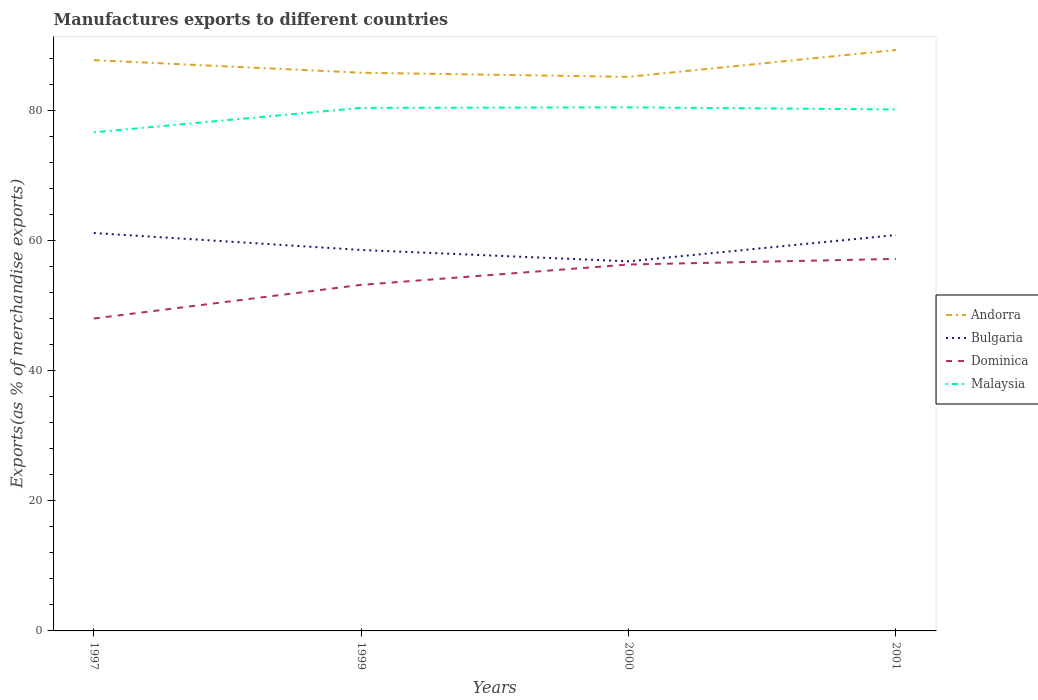How many different coloured lines are there?
Your response must be concise. 4. Is the number of lines equal to the number of legend labels?
Give a very brief answer. Yes. Across all years, what is the maximum percentage of exports to different countries in Bulgaria?
Offer a terse response. 56.77. What is the total percentage of exports to different countries in Andorra in the graph?
Make the answer very short. -1.56. What is the difference between the highest and the second highest percentage of exports to different countries in Bulgaria?
Give a very brief answer. 4.35. What is the difference between the highest and the lowest percentage of exports to different countries in Andorra?
Give a very brief answer. 2. Is the percentage of exports to different countries in Andorra strictly greater than the percentage of exports to different countries in Malaysia over the years?
Give a very brief answer. No. What is the difference between two consecutive major ticks on the Y-axis?
Offer a very short reply. 20. Does the graph contain any zero values?
Ensure brevity in your answer.  No. How are the legend labels stacked?
Your answer should be very brief. Vertical. What is the title of the graph?
Keep it short and to the point. Manufactures exports to different countries. What is the label or title of the Y-axis?
Your answer should be very brief. Exports(as % of merchandise exports). What is the Exports(as % of merchandise exports) of Andorra in 1997?
Your answer should be compact. 87.68. What is the Exports(as % of merchandise exports) in Bulgaria in 1997?
Keep it short and to the point. 61.13. What is the Exports(as % of merchandise exports) in Dominica in 1997?
Give a very brief answer. 47.99. What is the Exports(as % of merchandise exports) of Malaysia in 1997?
Offer a very short reply. 76.59. What is the Exports(as % of merchandise exports) in Andorra in 1999?
Your answer should be very brief. 85.75. What is the Exports(as % of merchandise exports) in Bulgaria in 1999?
Offer a terse response. 58.52. What is the Exports(as % of merchandise exports) in Dominica in 1999?
Offer a terse response. 53.16. What is the Exports(as % of merchandise exports) of Malaysia in 1999?
Your response must be concise. 80.35. What is the Exports(as % of merchandise exports) in Andorra in 2000?
Your answer should be compact. 85.12. What is the Exports(as % of merchandise exports) in Bulgaria in 2000?
Make the answer very short. 56.77. What is the Exports(as % of merchandise exports) of Dominica in 2000?
Give a very brief answer. 56.29. What is the Exports(as % of merchandise exports) in Malaysia in 2000?
Your answer should be compact. 80.43. What is the Exports(as % of merchandise exports) of Andorra in 2001?
Your answer should be compact. 89.24. What is the Exports(as % of merchandise exports) in Bulgaria in 2001?
Ensure brevity in your answer.  60.82. What is the Exports(as % of merchandise exports) in Dominica in 2001?
Offer a terse response. 57.15. What is the Exports(as % of merchandise exports) in Malaysia in 2001?
Offer a very short reply. 80.11. Across all years, what is the maximum Exports(as % of merchandise exports) of Andorra?
Your answer should be very brief. 89.24. Across all years, what is the maximum Exports(as % of merchandise exports) of Bulgaria?
Offer a very short reply. 61.13. Across all years, what is the maximum Exports(as % of merchandise exports) of Dominica?
Provide a succinct answer. 57.15. Across all years, what is the maximum Exports(as % of merchandise exports) of Malaysia?
Provide a succinct answer. 80.43. Across all years, what is the minimum Exports(as % of merchandise exports) in Andorra?
Offer a very short reply. 85.12. Across all years, what is the minimum Exports(as % of merchandise exports) in Bulgaria?
Your answer should be very brief. 56.77. Across all years, what is the minimum Exports(as % of merchandise exports) of Dominica?
Your answer should be compact. 47.99. Across all years, what is the minimum Exports(as % of merchandise exports) of Malaysia?
Offer a very short reply. 76.59. What is the total Exports(as % of merchandise exports) of Andorra in the graph?
Keep it short and to the point. 347.79. What is the total Exports(as % of merchandise exports) of Bulgaria in the graph?
Offer a very short reply. 237.24. What is the total Exports(as % of merchandise exports) in Dominica in the graph?
Provide a succinct answer. 214.59. What is the total Exports(as % of merchandise exports) of Malaysia in the graph?
Provide a short and direct response. 317.49. What is the difference between the Exports(as % of merchandise exports) in Andorra in 1997 and that in 1999?
Provide a short and direct response. 1.94. What is the difference between the Exports(as % of merchandise exports) in Bulgaria in 1997 and that in 1999?
Provide a succinct answer. 2.61. What is the difference between the Exports(as % of merchandise exports) in Dominica in 1997 and that in 1999?
Keep it short and to the point. -5.17. What is the difference between the Exports(as % of merchandise exports) in Malaysia in 1997 and that in 1999?
Keep it short and to the point. -3.76. What is the difference between the Exports(as % of merchandise exports) of Andorra in 1997 and that in 2000?
Provide a succinct answer. 2.57. What is the difference between the Exports(as % of merchandise exports) in Bulgaria in 1997 and that in 2000?
Your answer should be very brief. 4.35. What is the difference between the Exports(as % of merchandise exports) in Dominica in 1997 and that in 2000?
Ensure brevity in your answer.  -8.3. What is the difference between the Exports(as % of merchandise exports) of Malaysia in 1997 and that in 2000?
Your answer should be very brief. -3.84. What is the difference between the Exports(as % of merchandise exports) of Andorra in 1997 and that in 2001?
Keep it short and to the point. -1.56. What is the difference between the Exports(as % of merchandise exports) of Bulgaria in 1997 and that in 2001?
Provide a short and direct response. 0.31. What is the difference between the Exports(as % of merchandise exports) in Dominica in 1997 and that in 2001?
Provide a short and direct response. -9.16. What is the difference between the Exports(as % of merchandise exports) of Malaysia in 1997 and that in 2001?
Provide a short and direct response. -3.52. What is the difference between the Exports(as % of merchandise exports) in Andorra in 1999 and that in 2000?
Make the answer very short. 0.63. What is the difference between the Exports(as % of merchandise exports) in Bulgaria in 1999 and that in 2000?
Your answer should be very brief. 1.75. What is the difference between the Exports(as % of merchandise exports) of Dominica in 1999 and that in 2000?
Provide a short and direct response. -3.12. What is the difference between the Exports(as % of merchandise exports) in Malaysia in 1999 and that in 2000?
Keep it short and to the point. -0.08. What is the difference between the Exports(as % of merchandise exports) of Andorra in 1999 and that in 2001?
Make the answer very short. -3.49. What is the difference between the Exports(as % of merchandise exports) of Bulgaria in 1999 and that in 2001?
Offer a very short reply. -2.3. What is the difference between the Exports(as % of merchandise exports) in Dominica in 1999 and that in 2001?
Keep it short and to the point. -3.99. What is the difference between the Exports(as % of merchandise exports) in Malaysia in 1999 and that in 2001?
Keep it short and to the point. 0.24. What is the difference between the Exports(as % of merchandise exports) of Andorra in 2000 and that in 2001?
Your answer should be very brief. -4.12. What is the difference between the Exports(as % of merchandise exports) of Bulgaria in 2000 and that in 2001?
Ensure brevity in your answer.  -4.04. What is the difference between the Exports(as % of merchandise exports) of Dominica in 2000 and that in 2001?
Ensure brevity in your answer.  -0.86. What is the difference between the Exports(as % of merchandise exports) in Malaysia in 2000 and that in 2001?
Offer a very short reply. 0.32. What is the difference between the Exports(as % of merchandise exports) in Andorra in 1997 and the Exports(as % of merchandise exports) in Bulgaria in 1999?
Offer a very short reply. 29.16. What is the difference between the Exports(as % of merchandise exports) in Andorra in 1997 and the Exports(as % of merchandise exports) in Dominica in 1999?
Make the answer very short. 34.52. What is the difference between the Exports(as % of merchandise exports) in Andorra in 1997 and the Exports(as % of merchandise exports) in Malaysia in 1999?
Your answer should be compact. 7.33. What is the difference between the Exports(as % of merchandise exports) in Bulgaria in 1997 and the Exports(as % of merchandise exports) in Dominica in 1999?
Offer a terse response. 7.96. What is the difference between the Exports(as % of merchandise exports) of Bulgaria in 1997 and the Exports(as % of merchandise exports) of Malaysia in 1999?
Offer a very short reply. -19.23. What is the difference between the Exports(as % of merchandise exports) of Dominica in 1997 and the Exports(as % of merchandise exports) of Malaysia in 1999?
Offer a very short reply. -32.36. What is the difference between the Exports(as % of merchandise exports) in Andorra in 1997 and the Exports(as % of merchandise exports) in Bulgaria in 2000?
Ensure brevity in your answer.  30.91. What is the difference between the Exports(as % of merchandise exports) of Andorra in 1997 and the Exports(as % of merchandise exports) of Dominica in 2000?
Keep it short and to the point. 31.4. What is the difference between the Exports(as % of merchandise exports) in Andorra in 1997 and the Exports(as % of merchandise exports) in Malaysia in 2000?
Your response must be concise. 7.25. What is the difference between the Exports(as % of merchandise exports) in Bulgaria in 1997 and the Exports(as % of merchandise exports) in Dominica in 2000?
Keep it short and to the point. 4.84. What is the difference between the Exports(as % of merchandise exports) of Bulgaria in 1997 and the Exports(as % of merchandise exports) of Malaysia in 2000?
Your answer should be compact. -19.31. What is the difference between the Exports(as % of merchandise exports) in Dominica in 1997 and the Exports(as % of merchandise exports) in Malaysia in 2000?
Your answer should be very brief. -32.44. What is the difference between the Exports(as % of merchandise exports) in Andorra in 1997 and the Exports(as % of merchandise exports) in Bulgaria in 2001?
Make the answer very short. 26.87. What is the difference between the Exports(as % of merchandise exports) in Andorra in 1997 and the Exports(as % of merchandise exports) in Dominica in 2001?
Make the answer very short. 30.53. What is the difference between the Exports(as % of merchandise exports) of Andorra in 1997 and the Exports(as % of merchandise exports) of Malaysia in 2001?
Your answer should be very brief. 7.57. What is the difference between the Exports(as % of merchandise exports) in Bulgaria in 1997 and the Exports(as % of merchandise exports) in Dominica in 2001?
Offer a very short reply. 3.98. What is the difference between the Exports(as % of merchandise exports) of Bulgaria in 1997 and the Exports(as % of merchandise exports) of Malaysia in 2001?
Make the answer very short. -18.98. What is the difference between the Exports(as % of merchandise exports) in Dominica in 1997 and the Exports(as % of merchandise exports) in Malaysia in 2001?
Provide a short and direct response. -32.12. What is the difference between the Exports(as % of merchandise exports) of Andorra in 1999 and the Exports(as % of merchandise exports) of Bulgaria in 2000?
Offer a very short reply. 28.97. What is the difference between the Exports(as % of merchandise exports) in Andorra in 1999 and the Exports(as % of merchandise exports) in Dominica in 2000?
Provide a succinct answer. 29.46. What is the difference between the Exports(as % of merchandise exports) in Andorra in 1999 and the Exports(as % of merchandise exports) in Malaysia in 2000?
Your answer should be very brief. 5.31. What is the difference between the Exports(as % of merchandise exports) in Bulgaria in 1999 and the Exports(as % of merchandise exports) in Dominica in 2000?
Offer a terse response. 2.23. What is the difference between the Exports(as % of merchandise exports) in Bulgaria in 1999 and the Exports(as % of merchandise exports) in Malaysia in 2000?
Ensure brevity in your answer.  -21.91. What is the difference between the Exports(as % of merchandise exports) in Dominica in 1999 and the Exports(as % of merchandise exports) in Malaysia in 2000?
Your answer should be compact. -27.27. What is the difference between the Exports(as % of merchandise exports) of Andorra in 1999 and the Exports(as % of merchandise exports) of Bulgaria in 2001?
Make the answer very short. 24.93. What is the difference between the Exports(as % of merchandise exports) in Andorra in 1999 and the Exports(as % of merchandise exports) in Dominica in 2001?
Provide a succinct answer. 28.6. What is the difference between the Exports(as % of merchandise exports) of Andorra in 1999 and the Exports(as % of merchandise exports) of Malaysia in 2001?
Provide a succinct answer. 5.64. What is the difference between the Exports(as % of merchandise exports) of Bulgaria in 1999 and the Exports(as % of merchandise exports) of Dominica in 2001?
Give a very brief answer. 1.37. What is the difference between the Exports(as % of merchandise exports) in Bulgaria in 1999 and the Exports(as % of merchandise exports) in Malaysia in 2001?
Provide a succinct answer. -21.59. What is the difference between the Exports(as % of merchandise exports) in Dominica in 1999 and the Exports(as % of merchandise exports) in Malaysia in 2001?
Give a very brief answer. -26.95. What is the difference between the Exports(as % of merchandise exports) in Andorra in 2000 and the Exports(as % of merchandise exports) in Bulgaria in 2001?
Provide a succinct answer. 24.3. What is the difference between the Exports(as % of merchandise exports) of Andorra in 2000 and the Exports(as % of merchandise exports) of Dominica in 2001?
Make the answer very short. 27.97. What is the difference between the Exports(as % of merchandise exports) in Andorra in 2000 and the Exports(as % of merchandise exports) in Malaysia in 2001?
Give a very brief answer. 5.01. What is the difference between the Exports(as % of merchandise exports) of Bulgaria in 2000 and the Exports(as % of merchandise exports) of Dominica in 2001?
Offer a very short reply. -0.37. What is the difference between the Exports(as % of merchandise exports) in Bulgaria in 2000 and the Exports(as % of merchandise exports) in Malaysia in 2001?
Give a very brief answer. -23.34. What is the difference between the Exports(as % of merchandise exports) of Dominica in 2000 and the Exports(as % of merchandise exports) of Malaysia in 2001?
Your answer should be compact. -23.82. What is the average Exports(as % of merchandise exports) in Andorra per year?
Provide a succinct answer. 86.95. What is the average Exports(as % of merchandise exports) of Bulgaria per year?
Offer a very short reply. 59.31. What is the average Exports(as % of merchandise exports) of Dominica per year?
Your response must be concise. 53.65. What is the average Exports(as % of merchandise exports) in Malaysia per year?
Your response must be concise. 79.37. In the year 1997, what is the difference between the Exports(as % of merchandise exports) in Andorra and Exports(as % of merchandise exports) in Bulgaria?
Give a very brief answer. 26.56. In the year 1997, what is the difference between the Exports(as % of merchandise exports) of Andorra and Exports(as % of merchandise exports) of Dominica?
Your answer should be compact. 39.69. In the year 1997, what is the difference between the Exports(as % of merchandise exports) in Andorra and Exports(as % of merchandise exports) in Malaysia?
Provide a short and direct response. 11.09. In the year 1997, what is the difference between the Exports(as % of merchandise exports) of Bulgaria and Exports(as % of merchandise exports) of Dominica?
Keep it short and to the point. 13.14. In the year 1997, what is the difference between the Exports(as % of merchandise exports) of Bulgaria and Exports(as % of merchandise exports) of Malaysia?
Make the answer very short. -15.47. In the year 1997, what is the difference between the Exports(as % of merchandise exports) in Dominica and Exports(as % of merchandise exports) in Malaysia?
Provide a short and direct response. -28.61. In the year 1999, what is the difference between the Exports(as % of merchandise exports) of Andorra and Exports(as % of merchandise exports) of Bulgaria?
Offer a terse response. 27.23. In the year 1999, what is the difference between the Exports(as % of merchandise exports) in Andorra and Exports(as % of merchandise exports) in Dominica?
Give a very brief answer. 32.58. In the year 1999, what is the difference between the Exports(as % of merchandise exports) in Andorra and Exports(as % of merchandise exports) in Malaysia?
Your response must be concise. 5.4. In the year 1999, what is the difference between the Exports(as % of merchandise exports) in Bulgaria and Exports(as % of merchandise exports) in Dominica?
Ensure brevity in your answer.  5.36. In the year 1999, what is the difference between the Exports(as % of merchandise exports) of Bulgaria and Exports(as % of merchandise exports) of Malaysia?
Offer a very short reply. -21.83. In the year 1999, what is the difference between the Exports(as % of merchandise exports) in Dominica and Exports(as % of merchandise exports) in Malaysia?
Make the answer very short. -27.19. In the year 2000, what is the difference between the Exports(as % of merchandise exports) in Andorra and Exports(as % of merchandise exports) in Bulgaria?
Keep it short and to the point. 28.34. In the year 2000, what is the difference between the Exports(as % of merchandise exports) in Andorra and Exports(as % of merchandise exports) in Dominica?
Make the answer very short. 28.83. In the year 2000, what is the difference between the Exports(as % of merchandise exports) in Andorra and Exports(as % of merchandise exports) in Malaysia?
Keep it short and to the point. 4.69. In the year 2000, what is the difference between the Exports(as % of merchandise exports) of Bulgaria and Exports(as % of merchandise exports) of Dominica?
Keep it short and to the point. 0.49. In the year 2000, what is the difference between the Exports(as % of merchandise exports) in Bulgaria and Exports(as % of merchandise exports) in Malaysia?
Give a very brief answer. -23.66. In the year 2000, what is the difference between the Exports(as % of merchandise exports) in Dominica and Exports(as % of merchandise exports) in Malaysia?
Your answer should be very brief. -24.15. In the year 2001, what is the difference between the Exports(as % of merchandise exports) in Andorra and Exports(as % of merchandise exports) in Bulgaria?
Keep it short and to the point. 28.42. In the year 2001, what is the difference between the Exports(as % of merchandise exports) of Andorra and Exports(as % of merchandise exports) of Dominica?
Give a very brief answer. 32.09. In the year 2001, what is the difference between the Exports(as % of merchandise exports) of Andorra and Exports(as % of merchandise exports) of Malaysia?
Provide a succinct answer. 9.13. In the year 2001, what is the difference between the Exports(as % of merchandise exports) in Bulgaria and Exports(as % of merchandise exports) in Dominica?
Your answer should be very brief. 3.67. In the year 2001, what is the difference between the Exports(as % of merchandise exports) in Bulgaria and Exports(as % of merchandise exports) in Malaysia?
Give a very brief answer. -19.29. In the year 2001, what is the difference between the Exports(as % of merchandise exports) of Dominica and Exports(as % of merchandise exports) of Malaysia?
Your response must be concise. -22.96. What is the ratio of the Exports(as % of merchandise exports) in Andorra in 1997 to that in 1999?
Make the answer very short. 1.02. What is the ratio of the Exports(as % of merchandise exports) of Bulgaria in 1997 to that in 1999?
Provide a succinct answer. 1.04. What is the ratio of the Exports(as % of merchandise exports) of Dominica in 1997 to that in 1999?
Ensure brevity in your answer.  0.9. What is the ratio of the Exports(as % of merchandise exports) in Malaysia in 1997 to that in 1999?
Your response must be concise. 0.95. What is the ratio of the Exports(as % of merchandise exports) of Andorra in 1997 to that in 2000?
Ensure brevity in your answer.  1.03. What is the ratio of the Exports(as % of merchandise exports) in Bulgaria in 1997 to that in 2000?
Provide a short and direct response. 1.08. What is the ratio of the Exports(as % of merchandise exports) in Dominica in 1997 to that in 2000?
Your answer should be very brief. 0.85. What is the ratio of the Exports(as % of merchandise exports) in Malaysia in 1997 to that in 2000?
Your answer should be very brief. 0.95. What is the ratio of the Exports(as % of merchandise exports) in Andorra in 1997 to that in 2001?
Your answer should be compact. 0.98. What is the ratio of the Exports(as % of merchandise exports) of Dominica in 1997 to that in 2001?
Your answer should be compact. 0.84. What is the ratio of the Exports(as % of merchandise exports) of Malaysia in 1997 to that in 2001?
Provide a short and direct response. 0.96. What is the ratio of the Exports(as % of merchandise exports) in Andorra in 1999 to that in 2000?
Your answer should be very brief. 1.01. What is the ratio of the Exports(as % of merchandise exports) in Bulgaria in 1999 to that in 2000?
Ensure brevity in your answer.  1.03. What is the ratio of the Exports(as % of merchandise exports) in Dominica in 1999 to that in 2000?
Your answer should be compact. 0.94. What is the ratio of the Exports(as % of merchandise exports) of Andorra in 1999 to that in 2001?
Your response must be concise. 0.96. What is the ratio of the Exports(as % of merchandise exports) of Bulgaria in 1999 to that in 2001?
Offer a very short reply. 0.96. What is the ratio of the Exports(as % of merchandise exports) in Dominica in 1999 to that in 2001?
Offer a terse response. 0.93. What is the ratio of the Exports(as % of merchandise exports) in Andorra in 2000 to that in 2001?
Keep it short and to the point. 0.95. What is the ratio of the Exports(as % of merchandise exports) of Bulgaria in 2000 to that in 2001?
Ensure brevity in your answer.  0.93. What is the ratio of the Exports(as % of merchandise exports) of Dominica in 2000 to that in 2001?
Offer a terse response. 0.98. What is the difference between the highest and the second highest Exports(as % of merchandise exports) in Andorra?
Your answer should be very brief. 1.56. What is the difference between the highest and the second highest Exports(as % of merchandise exports) in Bulgaria?
Keep it short and to the point. 0.31. What is the difference between the highest and the second highest Exports(as % of merchandise exports) in Dominica?
Provide a succinct answer. 0.86. What is the difference between the highest and the second highest Exports(as % of merchandise exports) of Malaysia?
Make the answer very short. 0.08. What is the difference between the highest and the lowest Exports(as % of merchandise exports) of Andorra?
Your response must be concise. 4.12. What is the difference between the highest and the lowest Exports(as % of merchandise exports) in Bulgaria?
Make the answer very short. 4.35. What is the difference between the highest and the lowest Exports(as % of merchandise exports) of Dominica?
Give a very brief answer. 9.16. What is the difference between the highest and the lowest Exports(as % of merchandise exports) of Malaysia?
Ensure brevity in your answer.  3.84. 